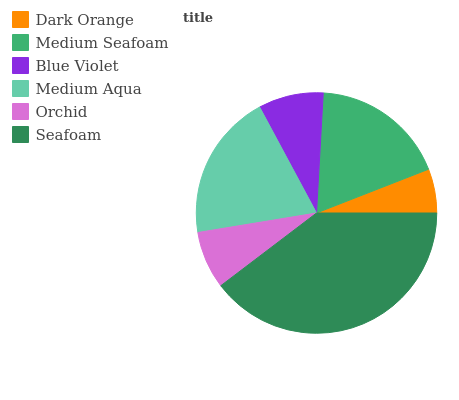Is Dark Orange the minimum?
Answer yes or no. Yes. Is Seafoam the maximum?
Answer yes or no. Yes. Is Medium Seafoam the minimum?
Answer yes or no. No. Is Medium Seafoam the maximum?
Answer yes or no. No. Is Medium Seafoam greater than Dark Orange?
Answer yes or no. Yes. Is Dark Orange less than Medium Seafoam?
Answer yes or no. Yes. Is Dark Orange greater than Medium Seafoam?
Answer yes or no. No. Is Medium Seafoam less than Dark Orange?
Answer yes or no. No. Is Medium Seafoam the high median?
Answer yes or no. Yes. Is Blue Violet the low median?
Answer yes or no. Yes. Is Blue Violet the high median?
Answer yes or no. No. Is Orchid the low median?
Answer yes or no. No. 